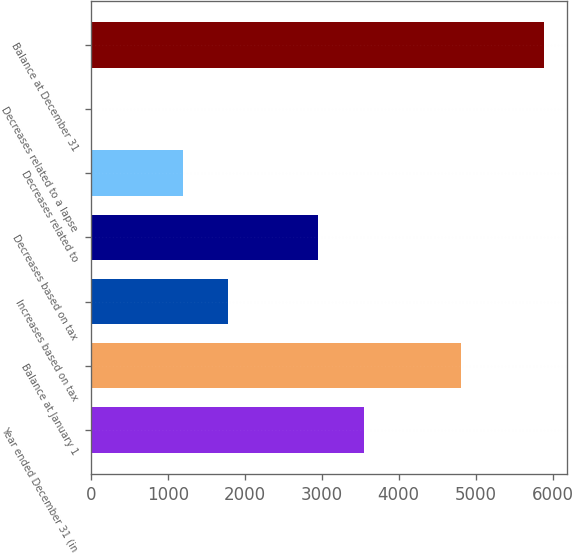Convert chart to OTSL. <chart><loc_0><loc_0><loc_500><loc_500><bar_chart><fcel>Year ended December 31 (in<fcel>Balance at January 1<fcel>Increases based on tax<fcel>Decreases based on tax<fcel>Decreases related to<fcel>Decreases related to a lapse<fcel>Balance at December 31<nl><fcel>3544<fcel>4811<fcel>1781.5<fcel>2956.5<fcel>1194<fcel>19<fcel>5894<nl></chart> 